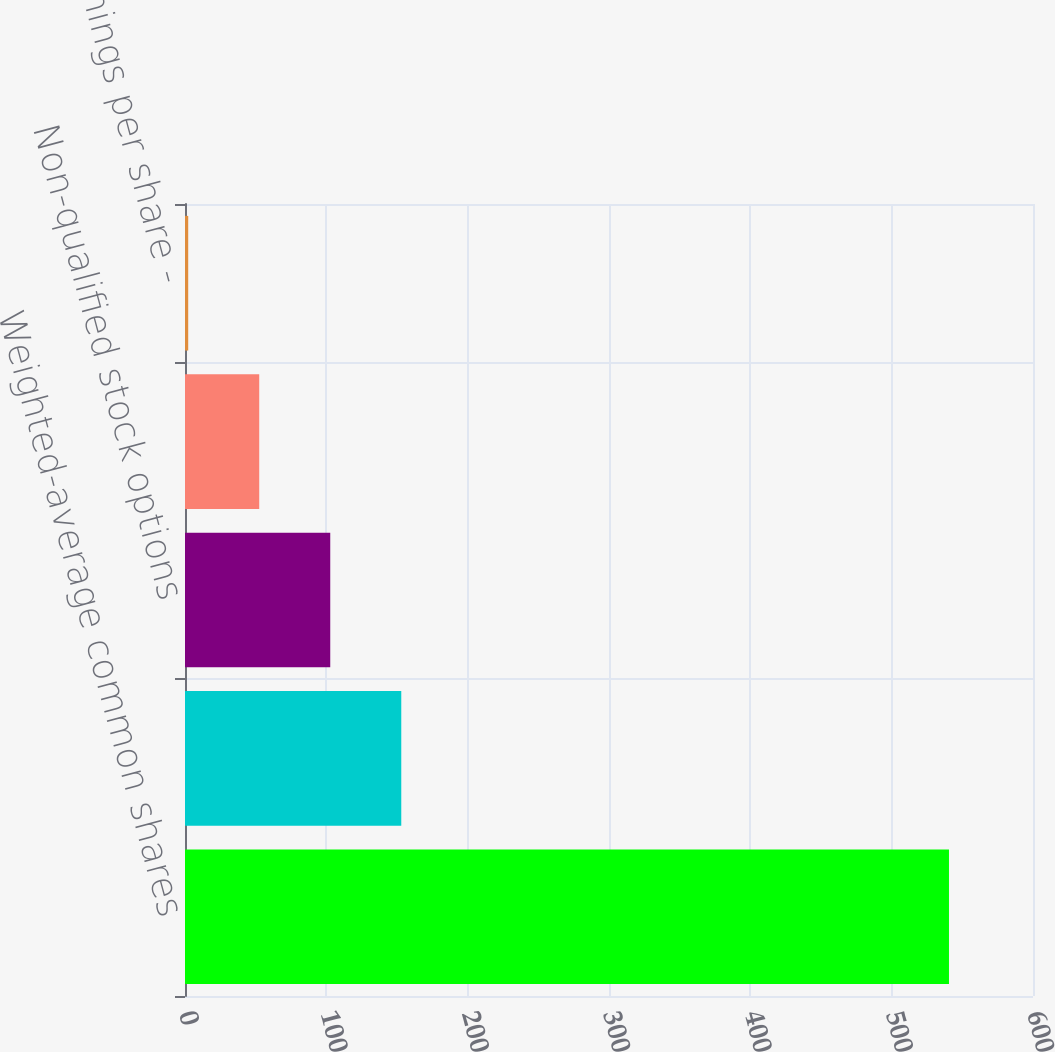Convert chart to OTSL. <chart><loc_0><loc_0><loc_500><loc_500><bar_chart><fcel>Weighted-average common shares<fcel>Shares from assumed conversion<fcel>Non-qualified stock options<fcel>Basic earnings per share -<fcel>Diluted earnings per share -<nl><fcel>540.55<fcel>153.02<fcel>102.77<fcel>52.52<fcel>2.27<nl></chart> 